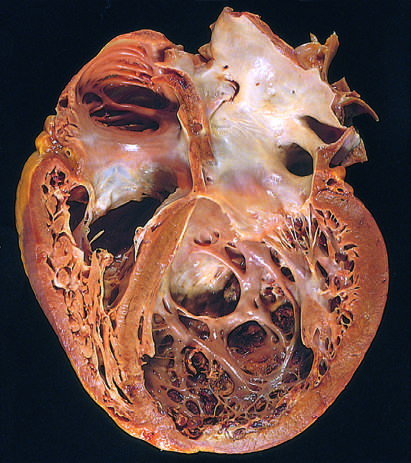how much dilation and hypertrophy are evident?
Answer the question using a single word or phrase. Four 